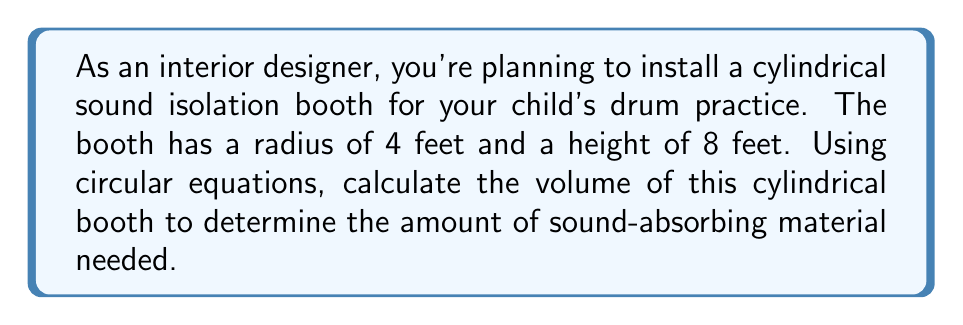Show me your answer to this math problem. To calculate the volume of a cylindrical sound isolation booth, we'll use the following steps:

1. Recall the equation for the volume of a cylinder:
   $$V = \pi r^2 h$$
   where $V$ is volume, $r$ is radius, and $h$ is height.

2. Given dimensions:
   Radius $(r) = 4$ feet
   Height $(h) = 8$ feet

3. Substitute the values into the equation:
   $$V = \pi (4\text{ ft})^2 (8\text{ ft})$$

4. Simplify:
   $$V = \pi (16\text{ ft}^2) (8\text{ ft})$$
   $$V = 128\pi\text{ ft}^3$$

5. Calculate the final value (rounded to two decimal places):
   $$V \approx 402.12\text{ ft}^3$$

[asy]
import geometry;

size(200);
real r = 4;
real h = 8;

path base = Circle((0,0), r);
path top = Circle((0,h), r);

draw(base);
draw(top);
draw((r,0)--(r,h));
draw((-r,0)--(-r,h));

label("r = 4 ft", (r/2,0), E);
label("h = 8 ft", (r,-h/2), E);

dot((0,0), red);
dot((0,h), red);
[/asy]
Answer: $402.12\text{ ft}^3$ 